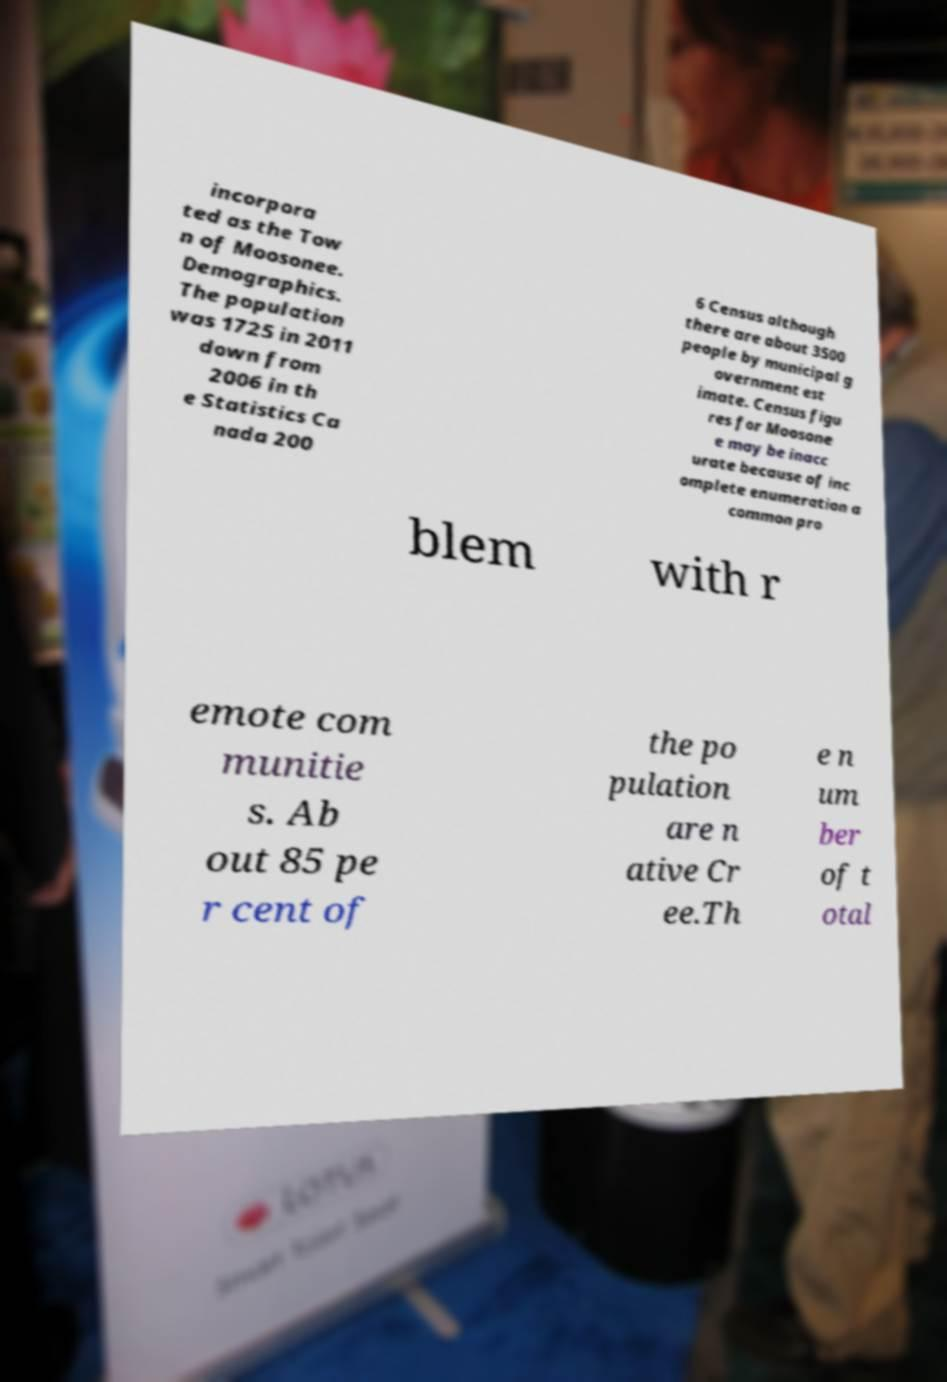I need the written content from this picture converted into text. Can you do that? incorpora ted as the Tow n of Moosonee. Demographics. The population was 1725 in 2011 down from 2006 in th e Statistics Ca nada 200 6 Census although there are about 3500 people by municipal g overnment est imate. Census figu res for Moosone e may be inacc urate because of inc omplete enumeration a common pro blem with r emote com munitie s. Ab out 85 pe r cent of the po pulation are n ative Cr ee.Th e n um ber of t otal 